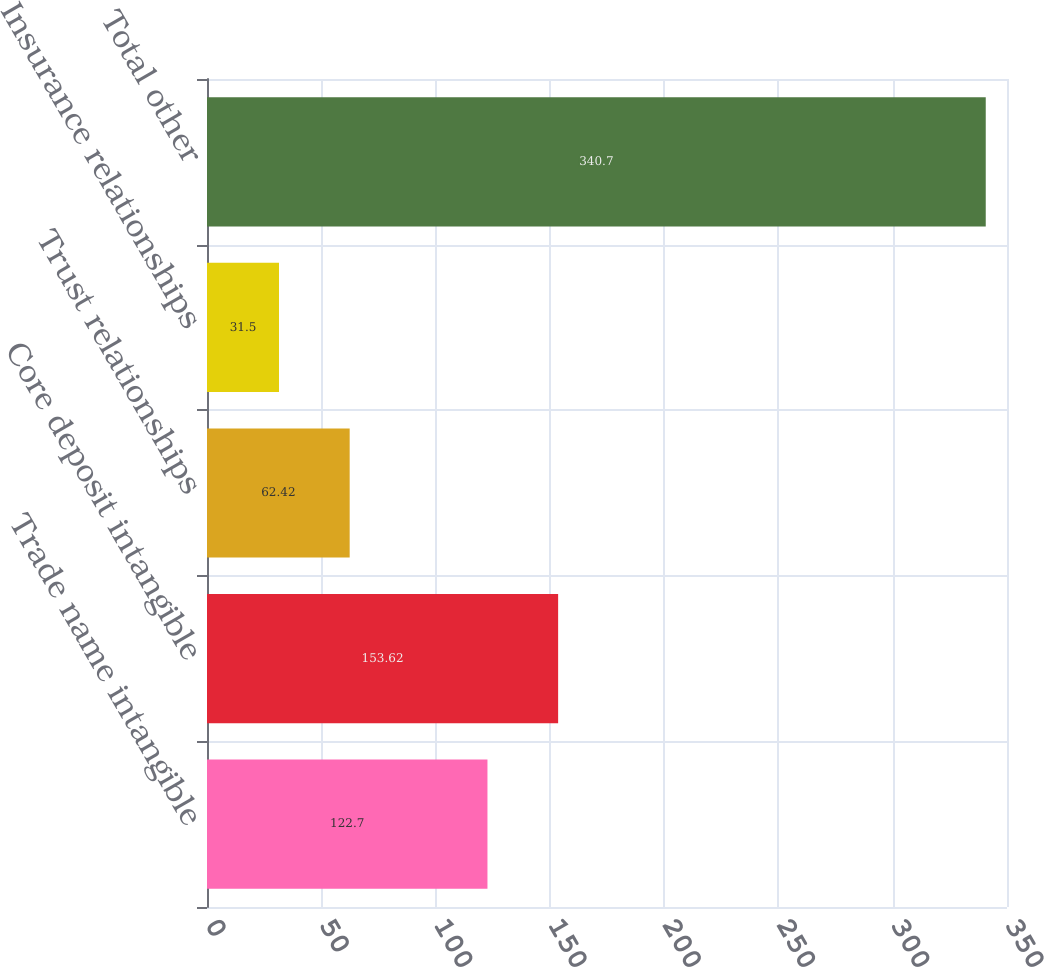Convert chart. <chart><loc_0><loc_0><loc_500><loc_500><bar_chart><fcel>Trade name intangible<fcel>Core deposit intangible<fcel>Trust relationships<fcel>Insurance relationships<fcel>Total other<nl><fcel>122.7<fcel>153.62<fcel>62.42<fcel>31.5<fcel>340.7<nl></chart> 